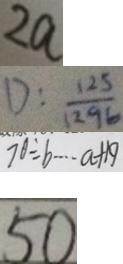<formula> <loc_0><loc_0><loc_500><loc_500>2 a 
 D : \frac { 1 2 5 } { 1 2 9 6 } 
 7 0 \div b \cdots a + 1 9 
 5 0</formula> 